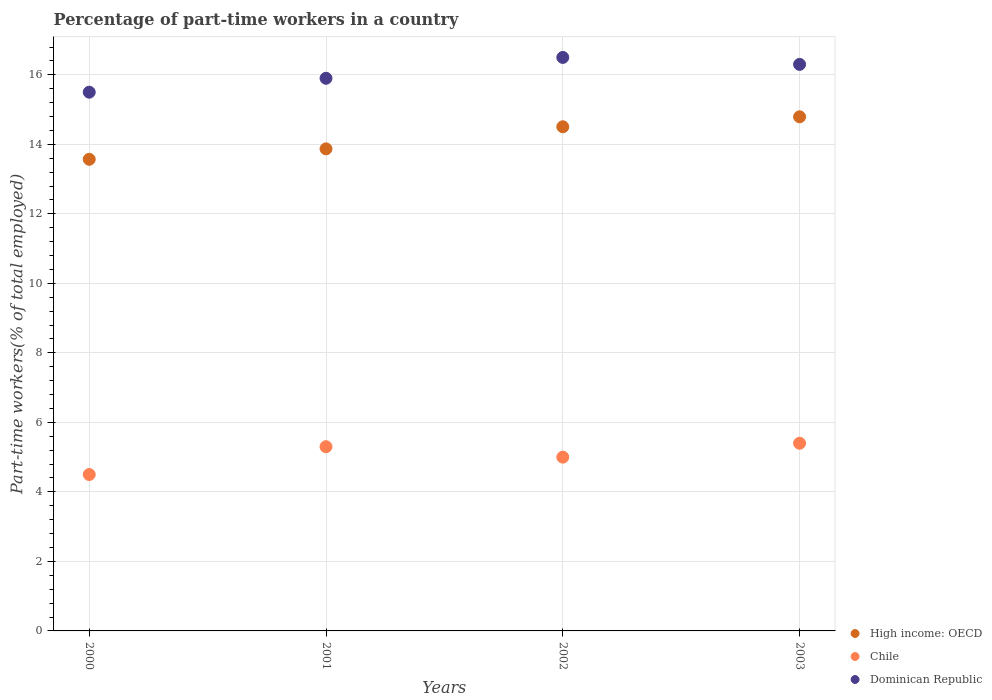What is the percentage of part-time workers in High income: OECD in 2002?
Keep it short and to the point. 14.51. Across all years, what is the maximum percentage of part-time workers in Dominican Republic?
Offer a very short reply. 16.5. In which year was the percentage of part-time workers in Chile minimum?
Offer a very short reply. 2000. What is the total percentage of part-time workers in High income: OECD in the graph?
Provide a succinct answer. 56.74. What is the difference between the percentage of part-time workers in Chile in 2000 and that in 2001?
Your response must be concise. -0.8. What is the difference between the percentage of part-time workers in Dominican Republic in 2003 and the percentage of part-time workers in High income: OECD in 2001?
Offer a terse response. 2.43. What is the average percentage of part-time workers in Dominican Republic per year?
Give a very brief answer. 16.05. In the year 2002, what is the difference between the percentage of part-time workers in High income: OECD and percentage of part-time workers in Chile?
Give a very brief answer. 9.51. What is the ratio of the percentage of part-time workers in High income: OECD in 2000 to that in 2003?
Provide a short and direct response. 0.92. Is the percentage of part-time workers in Chile in 2001 less than that in 2003?
Ensure brevity in your answer.  Yes. Is the difference between the percentage of part-time workers in High income: OECD in 2000 and 2002 greater than the difference between the percentage of part-time workers in Chile in 2000 and 2002?
Keep it short and to the point. No. What is the difference between the highest and the second highest percentage of part-time workers in High income: OECD?
Provide a short and direct response. 0.29. What is the difference between the highest and the lowest percentage of part-time workers in Dominican Republic?
Your answer should be compact. 1. Is it the case that in every year, the sum of the percentage of part-time workers in Dominican Republic and percentage of part-time workers in High income: OECD  is greater than the percentage of part-time workers in Chile?
Ensure brevity in your answer.  Yes. Does the percentage of part-time workers in Chile monotonically increase over the years?
Offer a very short reply. No. Is the percentage of part-time workers in Dominican Republic strictly less than the percentage of part-time workers in High income: OECD over the years?
Offer a terse response. No. How many dotlines are there?
Offer a terse response. 3. What is the difference between two consecutive major ticks on the Y-axis?
Offer a terse response. 2. Does the graph contain grids?
Your answer should be very brief. Yes. How many legend labels are there?
Your answer should be very brief. 3. What is the title of the graph?
Keep it short and to the point. Percentage of part-time workers in a country. Does "Fiji" appear as one of the legend labels in the graph?
Your response must be concise. No. What is the label or title of the Y-axis?
Your answer should be compact. Part-time workers(% of total employed). What is the Part-time workers(% of total employed) of High income: OECD in 2000?
Keep it short and to the point. 13.57. What is the Part-time workers(% of total employed) in High income: OECD in 2001?
Keep it short and to the point. 13.87. What is the Part-time workers(% of total employed) in Chile in 2001?
Offer a very short reply. 5.3. What is the Part-time workers(% of total employed) of Dominican Republic in 2001?
Keep it short and to the point. 15.9. What is the Part-time workers(% of total employed) in High income: OECD in 2002?
Ensure brevity in your answer.  14.51. What is the Part-time workers(% of total employed) in Chile in 2002?
Provide a succinct answer. 5. What is the Part-time workers(% of total employed) of High income: OECD in 2003?
Keep it short and to the point. 14.79. What is the Part-time workers(% of total employed) in Chile in 2003?
Your response must be concise. 5.4. What is the Part-time workers(% of total employed) in Dominican Republic in 2003?
Your response must be concise. 16.3. Across all years, what is the maximum Part-time workers(% of total employed) of High income: OECD?
Provide a short and direct response. 14.79. Across all years, what is the maximum Part-time workers(% of total employed) in Chile?
Your answer should be compact. 5.4. Across all years, what is the maximum Part-time workers(% of total employed) in Dominican Republic?
Keep it short and to the point. 16.5. Across all years, what is the minimum Part-time workers(% of total employed) in High income: OECD?
Keep it short and to the point. 13.57. What is the total Part-time workers(% of total employed) in High income: OECD in the graph?
Keep it short and to the point. 56.74. What is the total Part-time workers(% of total employed) of Chile in the graph?
Offer a very short reply. 20.2. What is the total Part-time workers(% of total employed) of Dominican Republic in the graph?
Keep it short and to the point. 64.2. What is the difference between the Part-time workers(% of total employed) of High income: OECD in 2000 and that in 2001?
Your answer should be very brief. -0.3. What is the difference between the Part-time workers(% of total employed) in Dominican Republic in 2000 and that in 2001?
Your answer should be compact. -0.4. What is the difference between the Part-time workers(% of total employed) in High income: OECD in 2000 and that in 2002?
Offer a terse response. -0.94. What is the difference between the Part-time workers(% of total employed) of Dominican Republic in 2000 and that in 2002?
Your answer should be compact. -1. What is the difference between the Part-time workers(% of total employed) of High income: OECD in 2000 and that in 2003?
Provide a short and direct response. -1.22. What is the difference between the Part-time workers(% of total employed) in Chile in 2000 and that in 2003?
Give a very brief answer. -0.9. What is the difference between the Part-time workers(% of total employed) of High income: OECD in 2001 and that in 2002?
Your response must be concise. -0.64. What is the difference between the Part-time workers(% of total employed) of High income: OECD in 2001 and that in 2003?
Give a very brief answer. -0.92. What is the difference between the Part-time workers(% of total employed) in High income: OECD in 2002 and that in 2003?
Offer a very short reply. -0.29. What is the difference between the Part-time workers(% of total employed) in Chile in 2002 and that in 2003?
Your answer should be compact. -0.4. What is the difference between the Part-time workers(% of total employed) of High income: OECD in 2000 and the Part-time workers(% of total employed) of Chile in 2001?
Your response must be concise. 8.27. What is the difference between the Part-time workers(% of total employed) in High income: OECD in 2000 and the Part-time workers(% of total employed) in Dominican Republic in 2001?
Give a very brief answer. -2.33. What is the difference between the Part-time workers(% of total employed) of High income: OECD in 2000 and the Part-time workers(% of total employed) of Chile in 2002?
Your response must be concise. 8.57. What is the difference between the Part-time workers(% of total employed) of High income: OECD in 2000 and the Part-time workers(% of total employed) of Dominican Republic in 2002?
Provide a succinct answer. -2.93. What is the difference between the Part-time workers(% of total employed) of Chile in 2000 and the Part-time workers(% of total employed) of Dominican Republic in 2002?
Provide a short and direct response. -12. What is the difference between the Part-time workers(% of total employed) in High income: OECD in 2000 and the Part-time workers(% of total employed) in Chile in 2003?
Offer a terse response. 8.17. What is the difference between the Part-time workers(% of total employed) of High income: OECD in 2000 and the Part-time workers(% of total employed) of Dominican Republic in 2003?
Give a very brief answer. -2.73. What is the difference between the Part-time workers(% of total employed) of Chile in 2000 and the Part-time workers(% of total employed) of Dominican Republic in 2003?
Make the answer very short. -11.8. What is the difference between the Part-time workers(% of total employed) in High income: OECD in 2001 and the Part-time workers(% of total employed) in Chile in 2002?
Provide a short and direct response. 8.87. What is the difference between the Part-time workers(% of total employed) in High income: OECD in 2001 and the Part-time workers(% of total employed) in Dominican Republic in 2002?
Your response must be concise. -2.63. What is the difference between the Part-time workers(% of total employed) in Chile in 2001 and the Part-time workers(% of total employed) in Dominican Republic in 2002?
Give a very brief answer. -11.2. What is the difference between the Part-time workers(% of total employed) in High income: OECD in 2001 and the Part-time workers(% of total employed) in Chile in 2003?
Offer a very short reply. 8.47. What is the difference between the Part-time workers(% of total employed) of High income: OECD in 2001 and the Part-time workers(% of total employed) of Dominican Republic in 2003?
Ensure brevity in your answer.  -2.43. What is the difference between the Part-time workers(% of total employed) of High income: OECD in 2002 and the Part-time workers(% of total employed) of Chile in 2003?
Your answer should be very brief. 9.11. What is the difference between the Part-time workers(% of total employed) of High income: OECD in 2002 and the Part-time workers(% of total employed) of Dominican Republic in 2003?
Your response must be concise. -1.79. What is the average Part-time workers(% of total employed) in High income: OECD per year?
Give a very brief answer. 14.18. What is the average Part-time workers(% of total employed) of Chile per year?
Provide a succinct answer. 5.05. What is the average Part-time workers(% of total employed) of Dominican Republic per year?
Offer a very short reply. 16.05. In the year 2000, what is the difference between the Part-time workers(% of total employed) of High income: OECD and Part-time workers(% of total employed) of Chile?
Keep it short and to the point. 9.07. In the year 2000, what is the difference between the Part-time workers(% of total employed) of High income: OECD and Part-time workers(% of total employed) of Dominican Republic?
Give a very brief answer. -1.93. In the year 2000, what is the difference between the Part-time workers(% of total employed) of Chile and Part-time workers(% of total employed) of Dominican Republic?
Offer a very short reply. -11. In the year 2001, what is the difference between the Part-time workers(% of total employed) of High income: OECD and Part-time workers(% of total employed) of Chile?
Make the answer very short. 8.57. In the year 2001, what is the difference between the Part-time workers(% of total employed) in High income: OECD and Part-time workers(% of total employed) in Dominican Republic?
Provide a short and direct response. -2.03. In the year 2001, what is the difference between the Part-time workers(% of total employed) in Chile and Part-time workers(% of total employed) in Dominican Republic?
Your answer should be very brief. -10.6. In the year 2002, what is the difference between the Part-time workers(% of total employed) of High income: OECD and Part-time workers(% of total employed) of Chile?
Provide a succinct answer. 9.51. In the year 2002, what is the difference between the Part-time workers(% of total employed) of High income: OECD and Part-time workers(% of total employed) of Dominican Republic?
Provide a succinct answer. -2. In the year 2002, what is the difference between the Part-time workers(% of total employed) of Chile and Part-time workers(% of total employed) of Dominican Republic?
Your answer should be very brief. -11.5. In the year 2003, what is the difference between the Part-time workers(% of total employed) in High income: OECD and Part-time workers(% of total employed) in Chile?
Offer a terse response. 9.39. In the year 2003, what is the difference between the Part-time workers(% of total employed) of High income: OECD and Part-time workers(% of total employed) of Dominican Republic?
Ensure brevity in your answer.  -1.51. What is the ratio of the Part-time workers(% of total employed) in High income: OECD in 2000 to that in 2001?
Give a very brief answer. 0.98. What is the ratio of the Part-time workers(% of total employed) in Chile in 2000 to that in 2001?
Ensure brevity in your answer.  0.85. What is the ratio of the Part-time workers(% of total employed) of Dominican Republic in 2000 to that in 2001?
Make the answer very short. 0.97. What is the ratio of the Part-time workers(% of total employed) in High income: OECD in 2000 to that in 2002?
Make the answer very short. 0.94. What is the ratio of the Part-time workers(% of total employed) of Chile in 2000 to that in 2002?
Your answer should be very brief. 0.9. What is the ratio of the Part-time workers(% of total employed) of Dominican Republic in 2000 to that in 2002?
Offer a very short reply. 0.94. What is the ratio of the Part-time workers(% of total employed) of High income: OECD in 2000 to that in 2003?
Your response must be concise. 0.92. What is the ratio of the Part-time workers(% of total employed) in Chile in 2000 to that in 2003?
Ensure brevity in your answer.  0.83. What is the ratio of the Part-time workers(% of total employed) of Dominican Republic in 2000 to that in 2003?
Give a very brief answer. 0.95. What is the ratio of the Part-time workers(% of total employed) of High income: OECD in 2001 to that in 2002?
Offer a terse response. 0.96. What is the ratio of the Part-time workers(% of total employed) in Chile in 2001 to that in 2002?
Your answer should be very brief. 1.06. What is the ratio of the Part-time workers(% of total employed) of Dominican Republic in 2001 to that in 2002?
Your answer should be very brief. 0.96. What is the ratio of the Part-time workers(% of total employed) in High income: OECD in 2001 to that in 2003?
Your answer should be compact. 0.94. What is the ratio of the Part-time workers(% of total employed) in Chile in 2001 to that in 2003?
Offer a very short reply. 0.98. What is the ratio of the Part-time workers(% of total employed) of Dominican Republic in 2001 to that in 2003?
Ensure brevity in your answer.  0.98. What is the ratio of the Part-time workers(% of total employed) of High income: OECD in 2002 to that in 2003?
Offer a terse response. 0.98. What is the ratio of the Part-time workers(% of total employed) of Chile in 2002 to that in 2003?
Offer a very short reply. 0.93. What is the ratio of the Part-time workers(% of total employed) of Dominican Republic in 2002 to that in 2003?
Your answer should be very brief. 1.01. What is the difference between the highest and the second highest Part-time workers(% of total employed) of High income: OECD?
Offer a terse response. 0.29. What is the difference between the highest and the second highest Part-time workers(% of total employed) of Chile?
Keep it short and to the point. 0.1. What is the difference between the highest and the lowest Part-time workers(% of total employed) in High income: OECD?
Ensure brevity in your answer.  1.22. What is the difference between the highest and the lowest Part-time workers(% of total employed) in Chile?
Provide a short and direct response. 0.9. What is the difference between the highest and the lowest Part-time workers(% of total employed) of Dominican Republic?
Your answer should be compact. 1. 